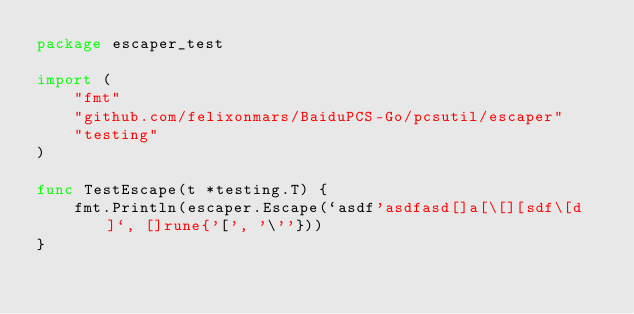Convert code to text. <code><loc_0><loc_0><loc_500><loc_500><_Go_>package escaper_test

import (
	"fmt"
	"github.com/felixonmars/BaiduPCS-Go/pcsutil/escaper"
	"testing"
)

func TestEscape(t *testing.T) {
	fmt.Println(escaper.Escape(`asdf'asdfasd[]a[\[][sdf\[d]`, []rune{'[', '\''}))
}
</code> 